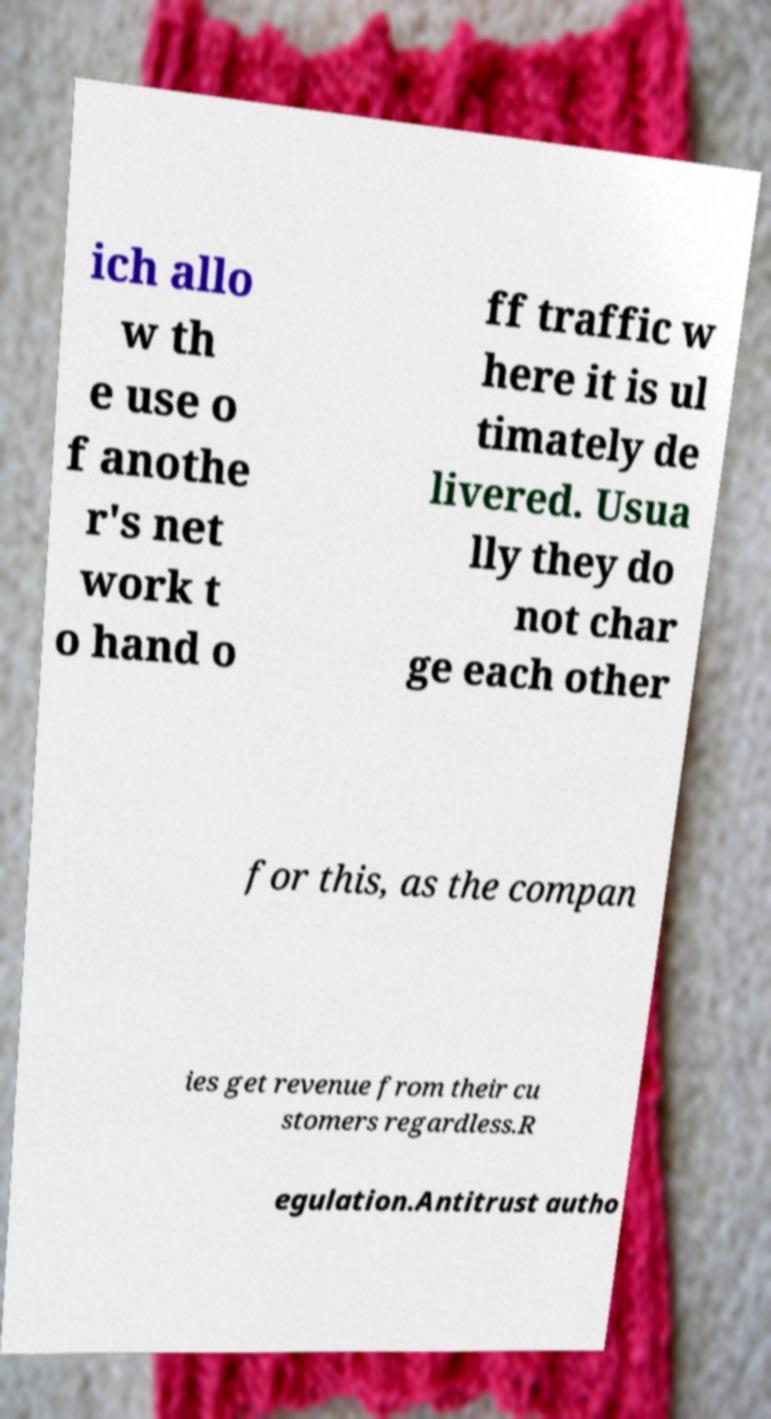For documentation purposes, I need the text within this image transcribed. Could you provide that? ich allo w th e use o f anothe r's net work t o hand o ff traffic w here it is ul timately de livered. Usua lly they do not char ge each other for this, as the compan ies get revenue from their cu stomers regardless.R egulation.Antitrust autho 